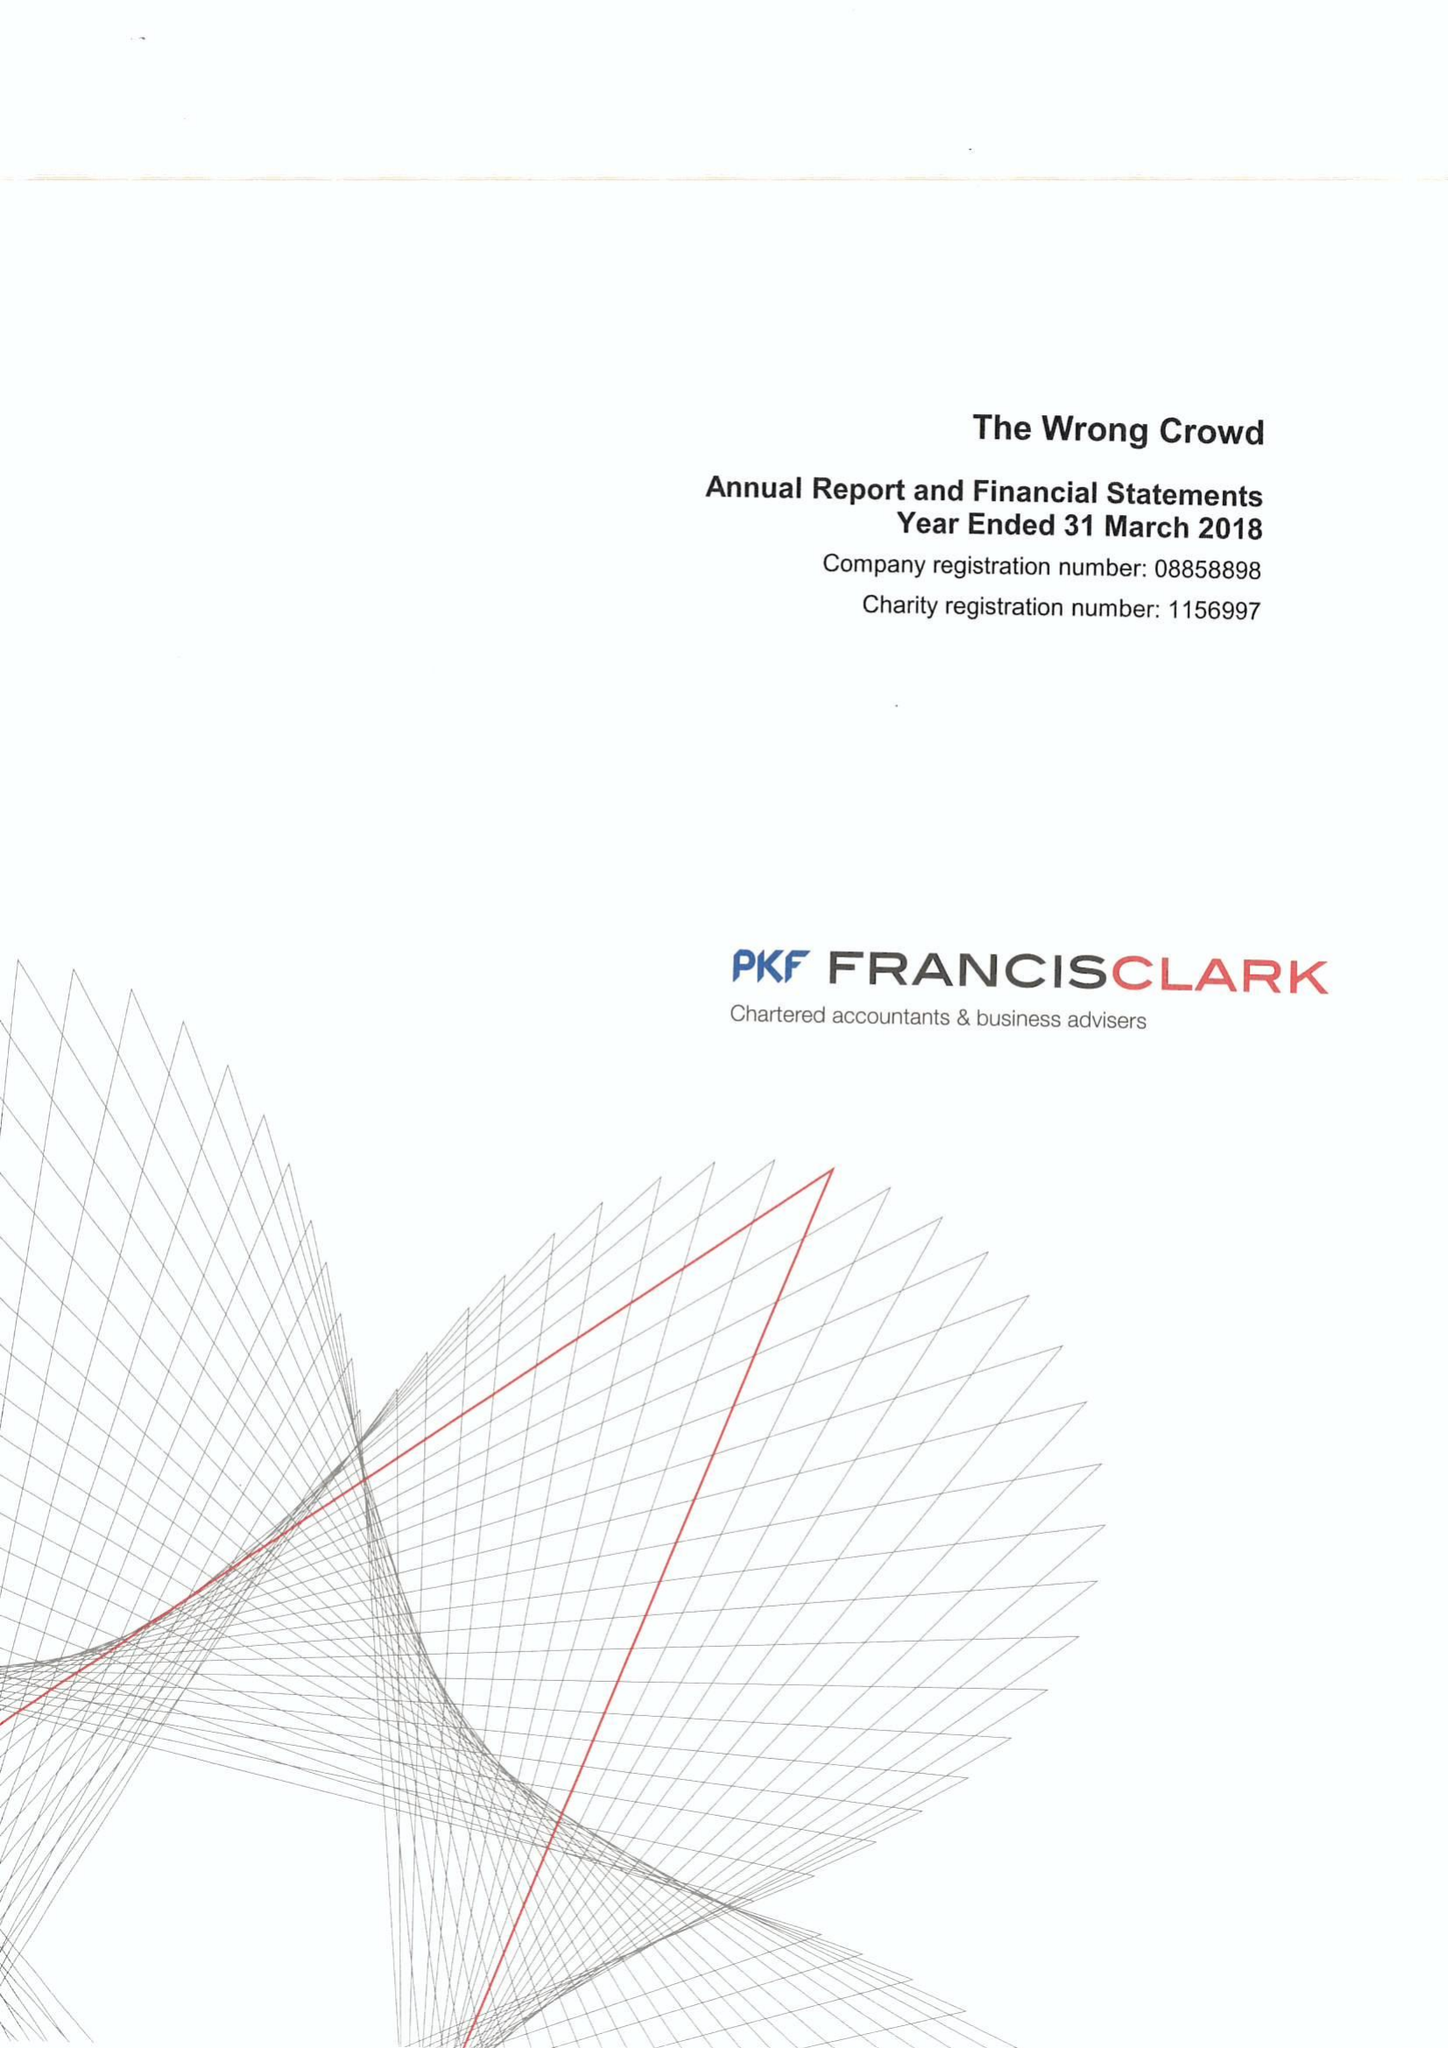What is the value for the income_annually_in_british_pounds?
Answer the question using a single word or phrase. 126394.00 